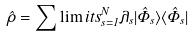<formula> <loc_0><loc_0><loc_500><loc_500>\hat { \rho } = \sum \lim i t s _ { s = 1 } ^ { N } \lambda _ { s } | \hat { \Phi } _ { s } \rangle \langle \hat { \Phi } _ { s } |</formula> 